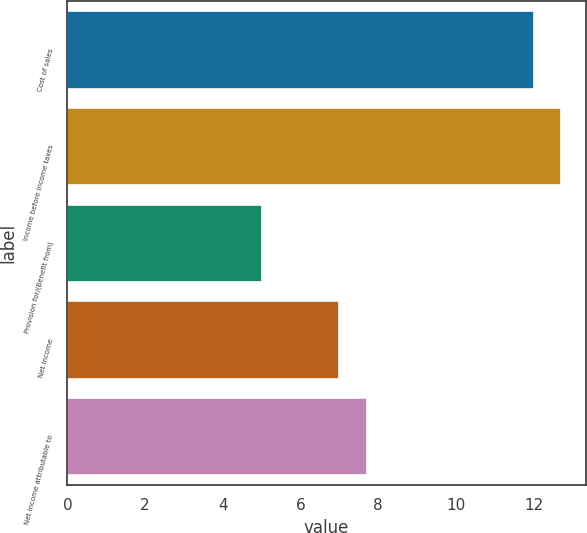<chart> <loc_0><loc_0><loc_500><loc_500><bar_chart><fcel>Cost of sales<fcel>Income before income taxes<fcel>Provision for/(Benefit from)<fcel>Net income<fcel>Net income attributable to<nl><fcel>12<fcel>12.7<fcel>5<fcel>7<fcel>7.7<nl></chart> 